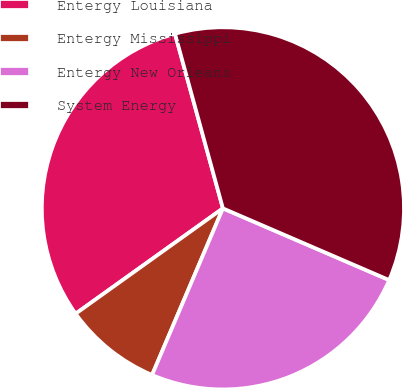<chart> <loc_0><loc_0><loc_500><loc_500><pie_chart><fcel>Entergy Louisiana<fcel>Entergy Mississippi<fcel>Entergy New Orleans<fcel>System Energy<nl><fcel>30.62%<fcel>8.72%<fcel>24.92%<fcel>35.75%<nl></chart> 